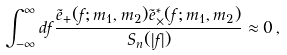Convert formula to latex. <formula><loc_0><loc_0><loc_500><loc_500>\int _ { - \infty } ^ { \infty } d f \frac { \tilde { e } _ { + } ( f ; m _ { 1 } , m _ { 2 } ) \tilde { e } ^ { \ast } _ { \times } ( f ; m _ { 1 } , m _ { 2 } ) } { S _ { n } ( | f | ) } \approx 0 \, ,</formula> 